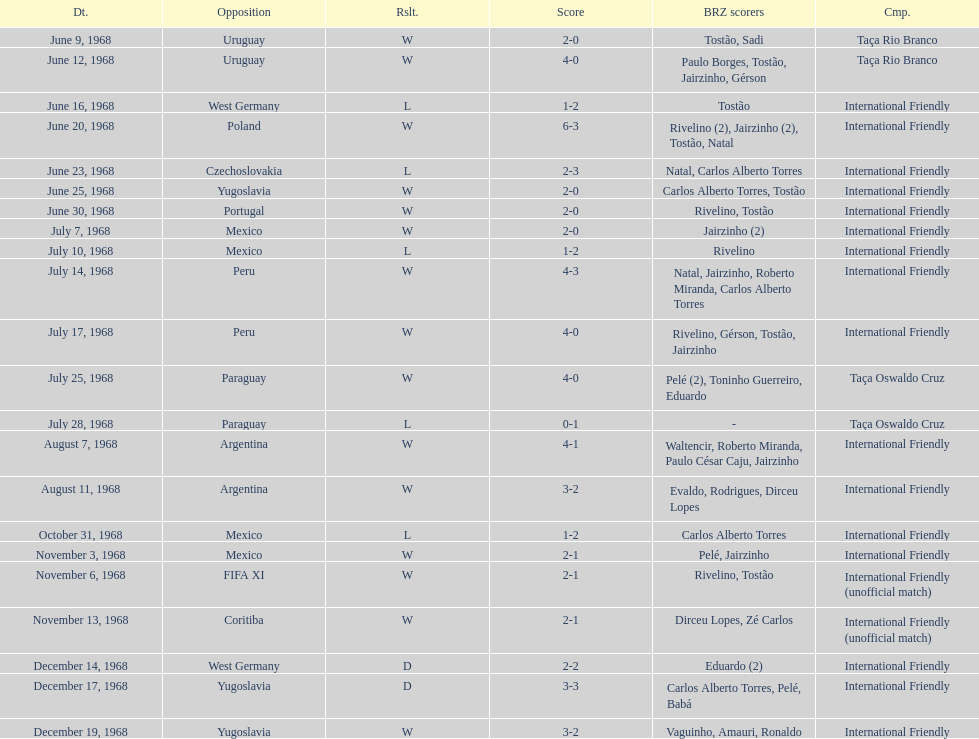What year has the highest scoring game? 1968. 